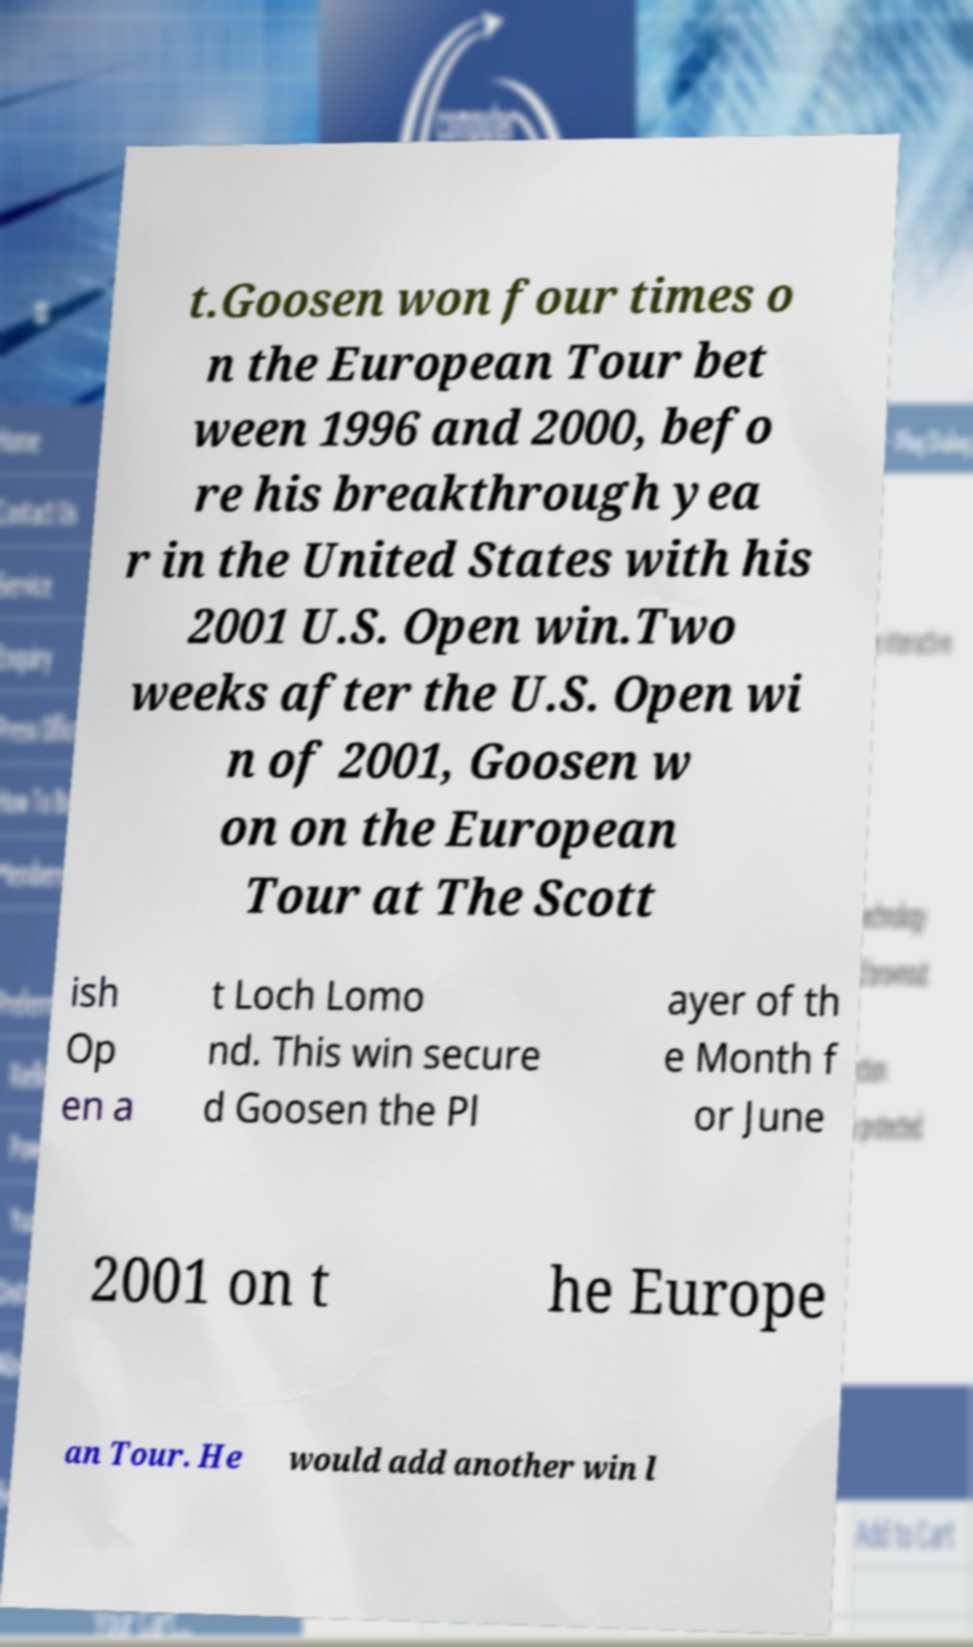Could you assist in decoding the text presented in this image and type it out clearly? t.Goosen won four times o n the European Tour bet ween 1996 and 2000, befo re his breakthrough yea r in the United States with his 2001 U.S. Open win.Two weeks after the U.S. Open wi n of 2001, Goosen w on on the European Tour at The Scott ish Op en a t Loch Lomo nd. This win secure d Goosen the Pl ayer of th e Month f or June 2001 on t he Europe an Tour. He would add another win l 